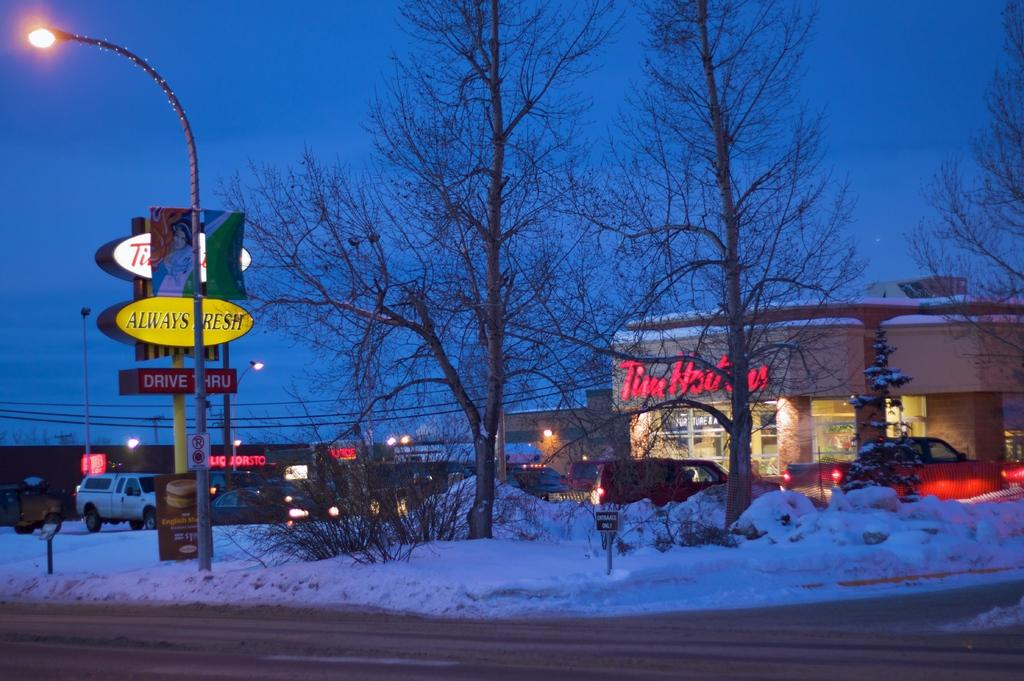<image>
Write a terse but informative summary of the picture. snow is covering the area around a tim hortons 